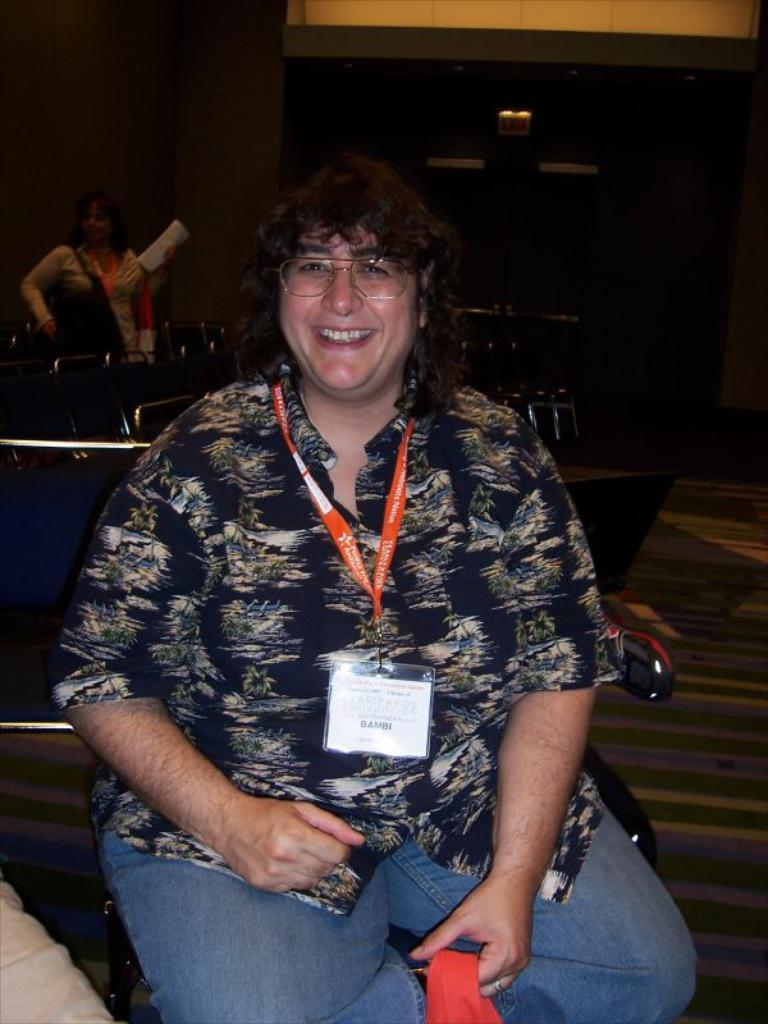What is the person in the image doing? The person in the image is sitting and smiling. What can be seen behind the sitting person? There are empty chairs behind the sitting person. What is the position of the other person in the image? There is another person standing in the image. What can be seen in the background of the image? There is an exit board visible in the background of the image. How much sugar is present in the ice that is not visible in the image? There is no ice present in the image, and therefore no sugar content can be determined. 